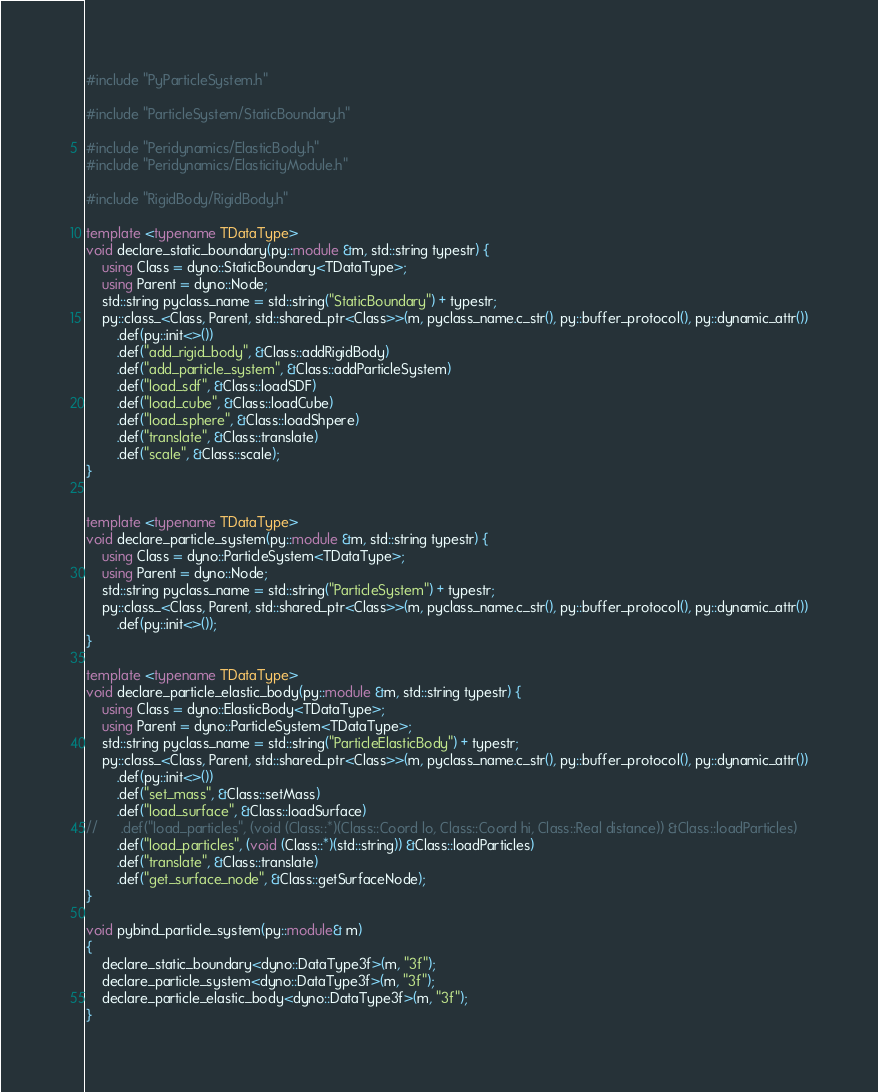<code> <loc_0><loc_0><loc_500><loc_500><_C++_>#include "PyParticleSystem.h"

#include "ParticleSystem/StaticBoundary.h"

#include "Peridynamics/ElasticBody.h"
#include "Peridynamics/ElasticityModule.h"

#include "RigidBody/RigidBody.h"

template <typename TDataType>
void declare_static_boundary(py::module &m, std::string typestr) {
	using Class = dyno::StaticBoundary<TDataType>;
	using Parent = dyno::Node;
	std::string pyclass_name = std::string("StaticBoundary") + typestr;
	py::class_<Class, Parent, std::shared_ptr<Class>>(m, pyclass_name.c_str(), py::buffer_protocol(), py::dynamic_attr())
		.def(py::init<>())
		.def("add_rigid_body", &Class::addRigidBody)
		.def("add_particle_system", &Class::addParticleSystem)
		.def("load_sdf", &Class::loadSDF)
		.def("load_cube", &Class::loadCube)
		.def("load_sphere", &Class::loadShpere)
		.def("translate", &Class::translate)
		.def("scale", &Class::scale);
}


template <typename TDataType>
void declare_particle_system(py::module &m, std::string typestr) {
	using Class = dyno::ParticleSystem<TDataType>;
	using Parent = dyno::Node;
	std::string pyclass_name = std::string("ParticleSystem") + typestr;
	py::class_<Class, Parent, std::shared_ptr<Class>>(m, pyclass_name.c_str(), py::buffer_protocol(), py::dynamic_attr())
		.def(py::init<>());
}

template <typename TDataType>
void declare_particle_elastic_body(py::module &m, std::string typestr) {
	using Class = dyno::ElasticBody<TDataType>;
	using Parent = dyno::ParticleSystem<TDataType>;
	std::string pyclass_name = std::string("ParticleElasticBody") + typestr;
	py::class_<Class, Parent, std::shared_ptr<Class>>(m, pyclass_name.c_str(), py::buffer_protocol(), py::dynamic_attr())
		.def(py::init<>())
		.def("set_mass", &Class::setMass)
		.def("load_surface", &Class::loadSurface)
//		.def("load_particles", (void (Class::*)(Class::Coord lo, Class::Coord hi, Class::Real distance)) &Class::loadParticles)
		.def("load_particles", (void (Class::*)(std::string)) &Class::loadParticles)
		.def("translate", &Class::translate)
		.def("get_surface_node", &Class::getSurfaceNode);
}

void pybind_particle_system(py::module& m)
{
	declare_static_boundary<dyno::DataType3f>(m, "3f");
	declare_particle_system<dyno::DataType3f>(m, "3f");
	declare_particle_elastic_body<dyno::DataType3f>(m, "3f");
}

</code> 